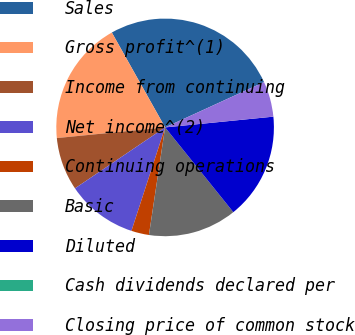Convert chart. <chart><loc_0><loc_0><loc_500><loc_500><pie_chart><fcel>Sales<fcel>Gross profit^(1)<fcel>Income from continuing<fcel>Net income^(2)<fcel>Continuing operations<fcel>Basic<fcel>Diluted<fcel>Cash dividends declared per<fcel>Closing price of common stock<nl><fcel>26.31%<fcel>18.42%<fcel>7.9%<fcel>10.53%<fcel>2.63%<fcel>13.16%<fcel>15.79%<fcel>0.0%<fcel>5.26%<nl></chart> 